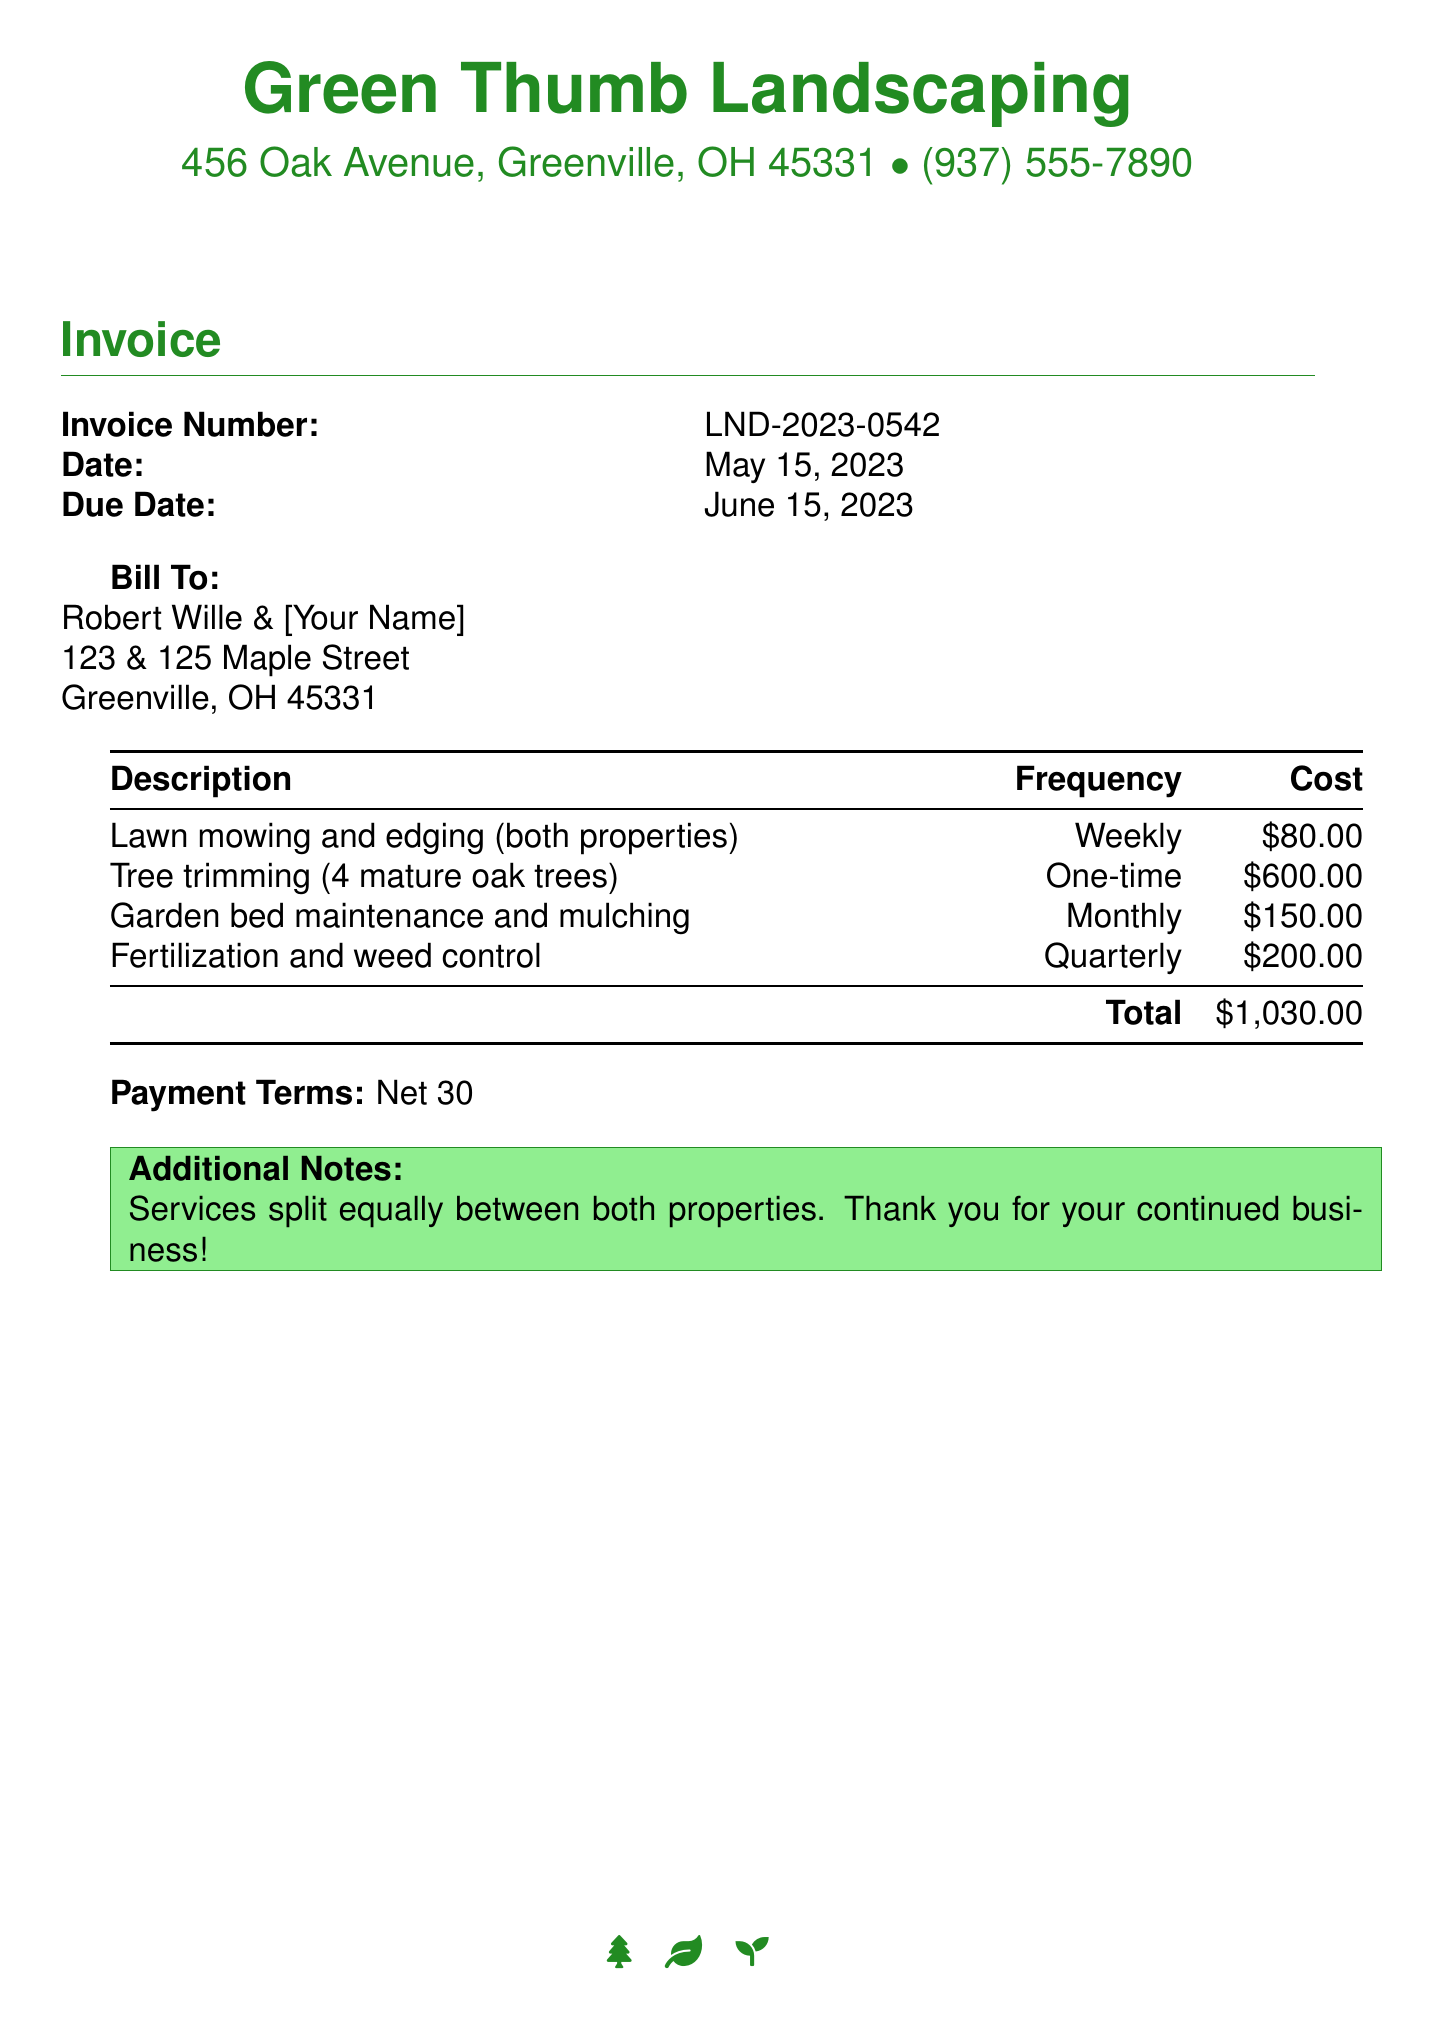What is the invoice number? The invoice number is located at the top of the invoice section, labeled as Invoice Number.
Answer: LND-2023-0542 What is the total amount due? The total amount due is listed at the bottom of the cost table, labeled as Total.
Answer: $1,030.00 When is the payment due? The due date for payment is provided in the invoice details, labeled as Due Date.
Answer: June 15, 2023 How often is lawn mowing and edging performed? The frequency of lawn mowing and edging is mentioned in the description section of the cost table.
Answer: Weekly What services are included in the invoice for both properties? The services listed in the table include lawn mowing, tree trimming, garden maintenance, and others, which are detailed in the description.
Answer: Lawn mowing, tree trimming, garden maintenance, fertilization, and weed control What is the cost for tree trimming? The cost for tree trimming is specified in the cost table under that service's description.
Answer: $600.00 What additional notes are mentioned? Additional notes are provided at the bottom of the invoice, indicating how the services are shared.
Answer: Services split equally between both properties. Thank you for your continued business! How frequently is garden bed maintenance performed? The frequency of garden bed maintenance is included in the service description in the cost table.
Answer: Monthly 